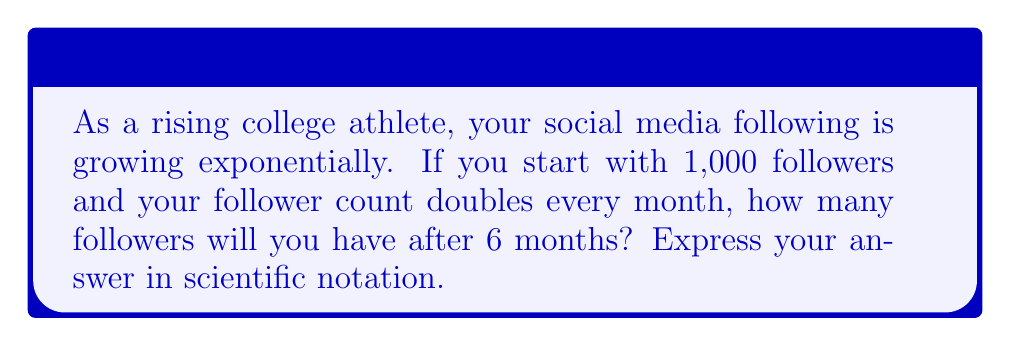Show me your answer to this math problem. Let's approach this step-by-step:

1) We start with 1,000 followers.

2) The number of followers doubles every month, which means we're multiplying by 2 each month.

3) We need to calculate this for 6 months, so we're essentially calculating:

   $1000 \cdot 2^6$

4) Let's break this down:
   
   $1000 \cdot 2^6 = 1000 \cdot 64$

   This is because $2^6 = 2 \cdot 2 \cdot 2 \cdot 2 \cdot 2 \cdot 2 = 64$

5) Now we calculate:

   $1000 \cdot 64 = 64,000$

6) To express this in scientific notation, we move the decimal point 4 places to the left:

   $64,000 = 6.4 \times 10^4$

Therefore, after 6 months, you will have $6.4 \times 10^4$ followers.
Answer: $6.4 \times 10^4$ 